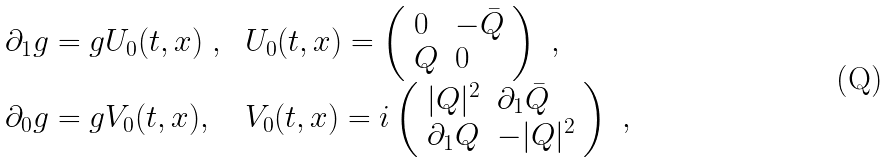<formula> <loc_0><loc_0><loc_500><loc_500>\begin{array} { l l } \partial _ { 1 } g = g U _ { 0 } ( t , x ) \ , & U _ { 0 } ( t , x ) = \left ( \begin{array} { l l } 0 & - \bar { Q } \\ Q & 0 \end{array} \right ) \ , \\ \partial _ { 0 } g = g V _ { 0 } ( t , x ) , \ \ & V _ { 0 } ( t , x ) = i \left ( \begin{array} { l l } | Q | ^ { 2 } & \partial _ { 1 } \bar { Q } \\ \partial _ { 1 } Q & - | Q | ^ { 2 } \end{array} \right ) \ , \end{array}</formula> 